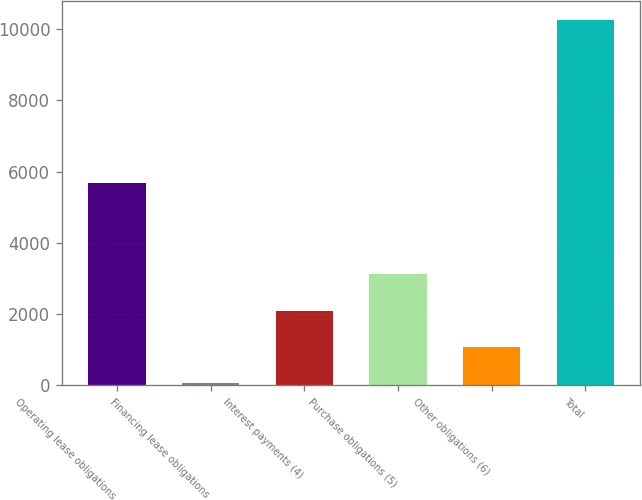Convert chart. <chart><loc_0><loc_0><loc_500><loc_500><bar_chart><fcel>Operating lease obligations<fcel>Financing lease obligations<fcel>Interest payments (4)<fcel>Purchase obligations (5)<fcel>Other obligations (6)<fcel>Total<nl><fcel>5669.5<fcel>47.1<fcel>2091.2<fcel>3113.25<fcel>1069.15<fcel>10267.6<nl></chart> 